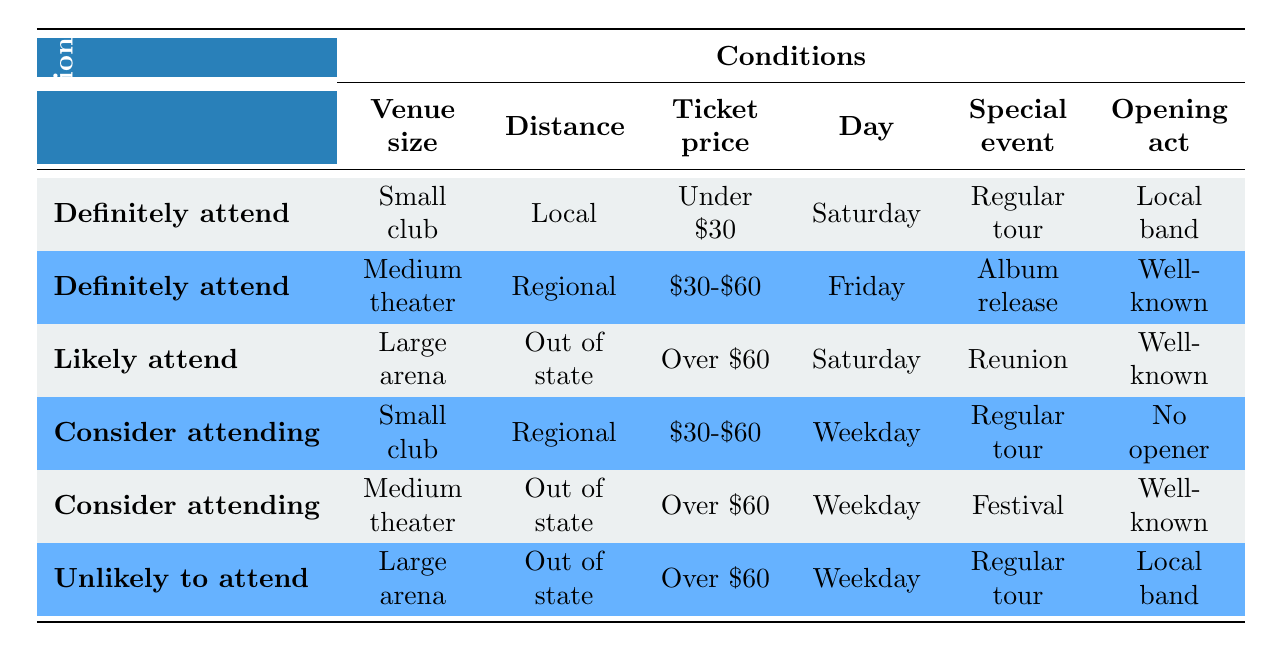What attendance decision applies for a small club concert that is local, costs under $30, is on a Saturday, is a regular tour, and has a local band? This situation matches the first row of the table, which indicates a definite attendance decision for the specified conditions.
Answer: Definitely attend Is there a situation where one would likely attend a concert at a large arena if it is out of state and costs over $60? Yes, the third row specifies that if it is a reunion concert on a Saturday, then the decision would be likely to attend.
Answer: Yes What are the conditions for a "Consider attending" decision? There are two rows for "Consider attending." The first row states: Small club, Regional (50-200 miles), $30-$60, Weekday, Regular tour, No opener. The second row states: Medium theater, Out of state (> 200 miles), Over $60, Weekday, Festival appearance, Well-known artist.
Answer: Small club, Regional, $30-$60, Weekday, Regular tour, No opener; Medium theater, Out of state, Over $60, Weekday, Festival, Well-known Can you identify a concert condition that would lead to an "Unlikely to attend" decision? Yes, according to the sixth row, conditions that would lead to an "Unlikely to attend" decision occur with a large arena, out of state, ticket price over $60, on a weekday, regular tour, with a local band.
Answer: Yes What is the relation between the day of the week and attendance decision for the Medium theater with a well-known opening act? The second row indicates a "Definitely attend" decision for a Medium theater on a Friday with conditions of a Regional distance, ticket price $30-$60, and an album release show with a well-known opening act. Therefore, Fridays help lead to a definite attendance decision.
Answer: Definitely attend If an event is a festival appearance on a weekday and the ticket price is over $60, what is the attendance decision based on the table? According to the fifth row, the attendance decision would be "Consider attending" for such an event if it is in a Medium theater and out-of-state with a well-known artist.
Answer: Consider attending Is it possible to attend a concert featuring no opener at a small club on a weekday? Yes, the fourth row shows that it would lead to a "Consider attending" decision in this scenario.
Answer: Yes What could be the average ticket price for concerts that lead to a "Definitely attend" decision? The average can be calculated from two rows: Under $30 and $30-$60. The ticket prices are 30 (considering the midpoint of $30-$60; $45). So, the average is (30+45)/2 = 37.5.
Answer: 37.5 